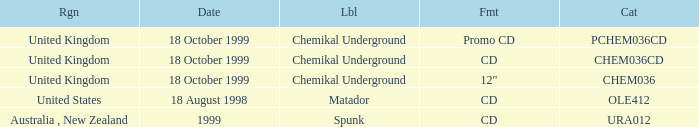What label is associated with the United Kingdom and the chem036 catalog? Chemikal Underground. 